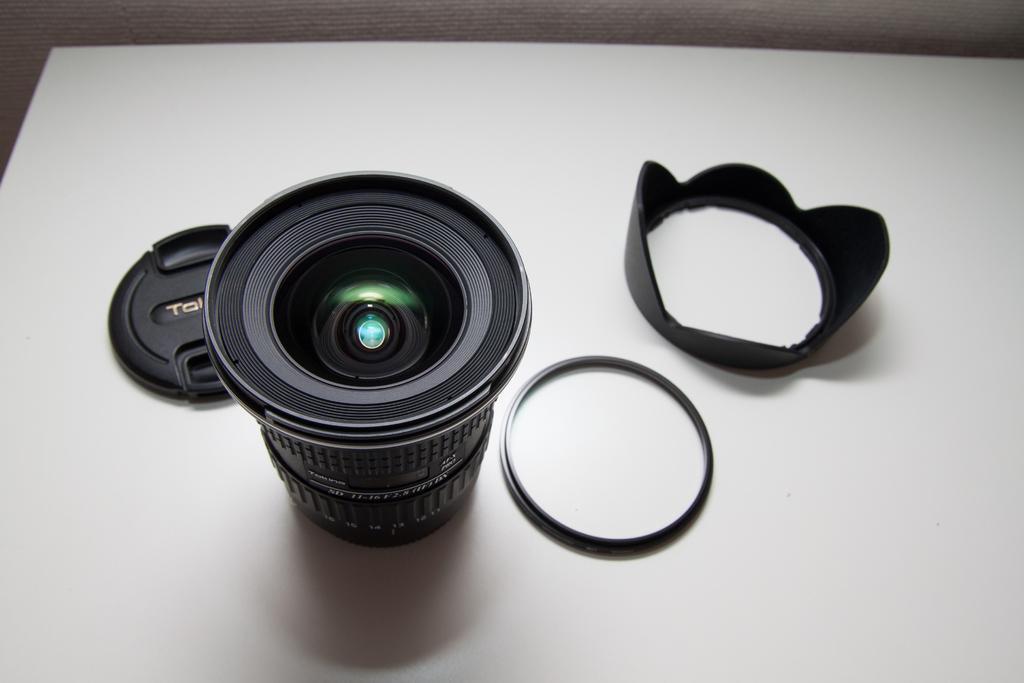Please provide a concise description of this image. In this image we can see a camera lens, caps, and two other objects on the white colored surface. 